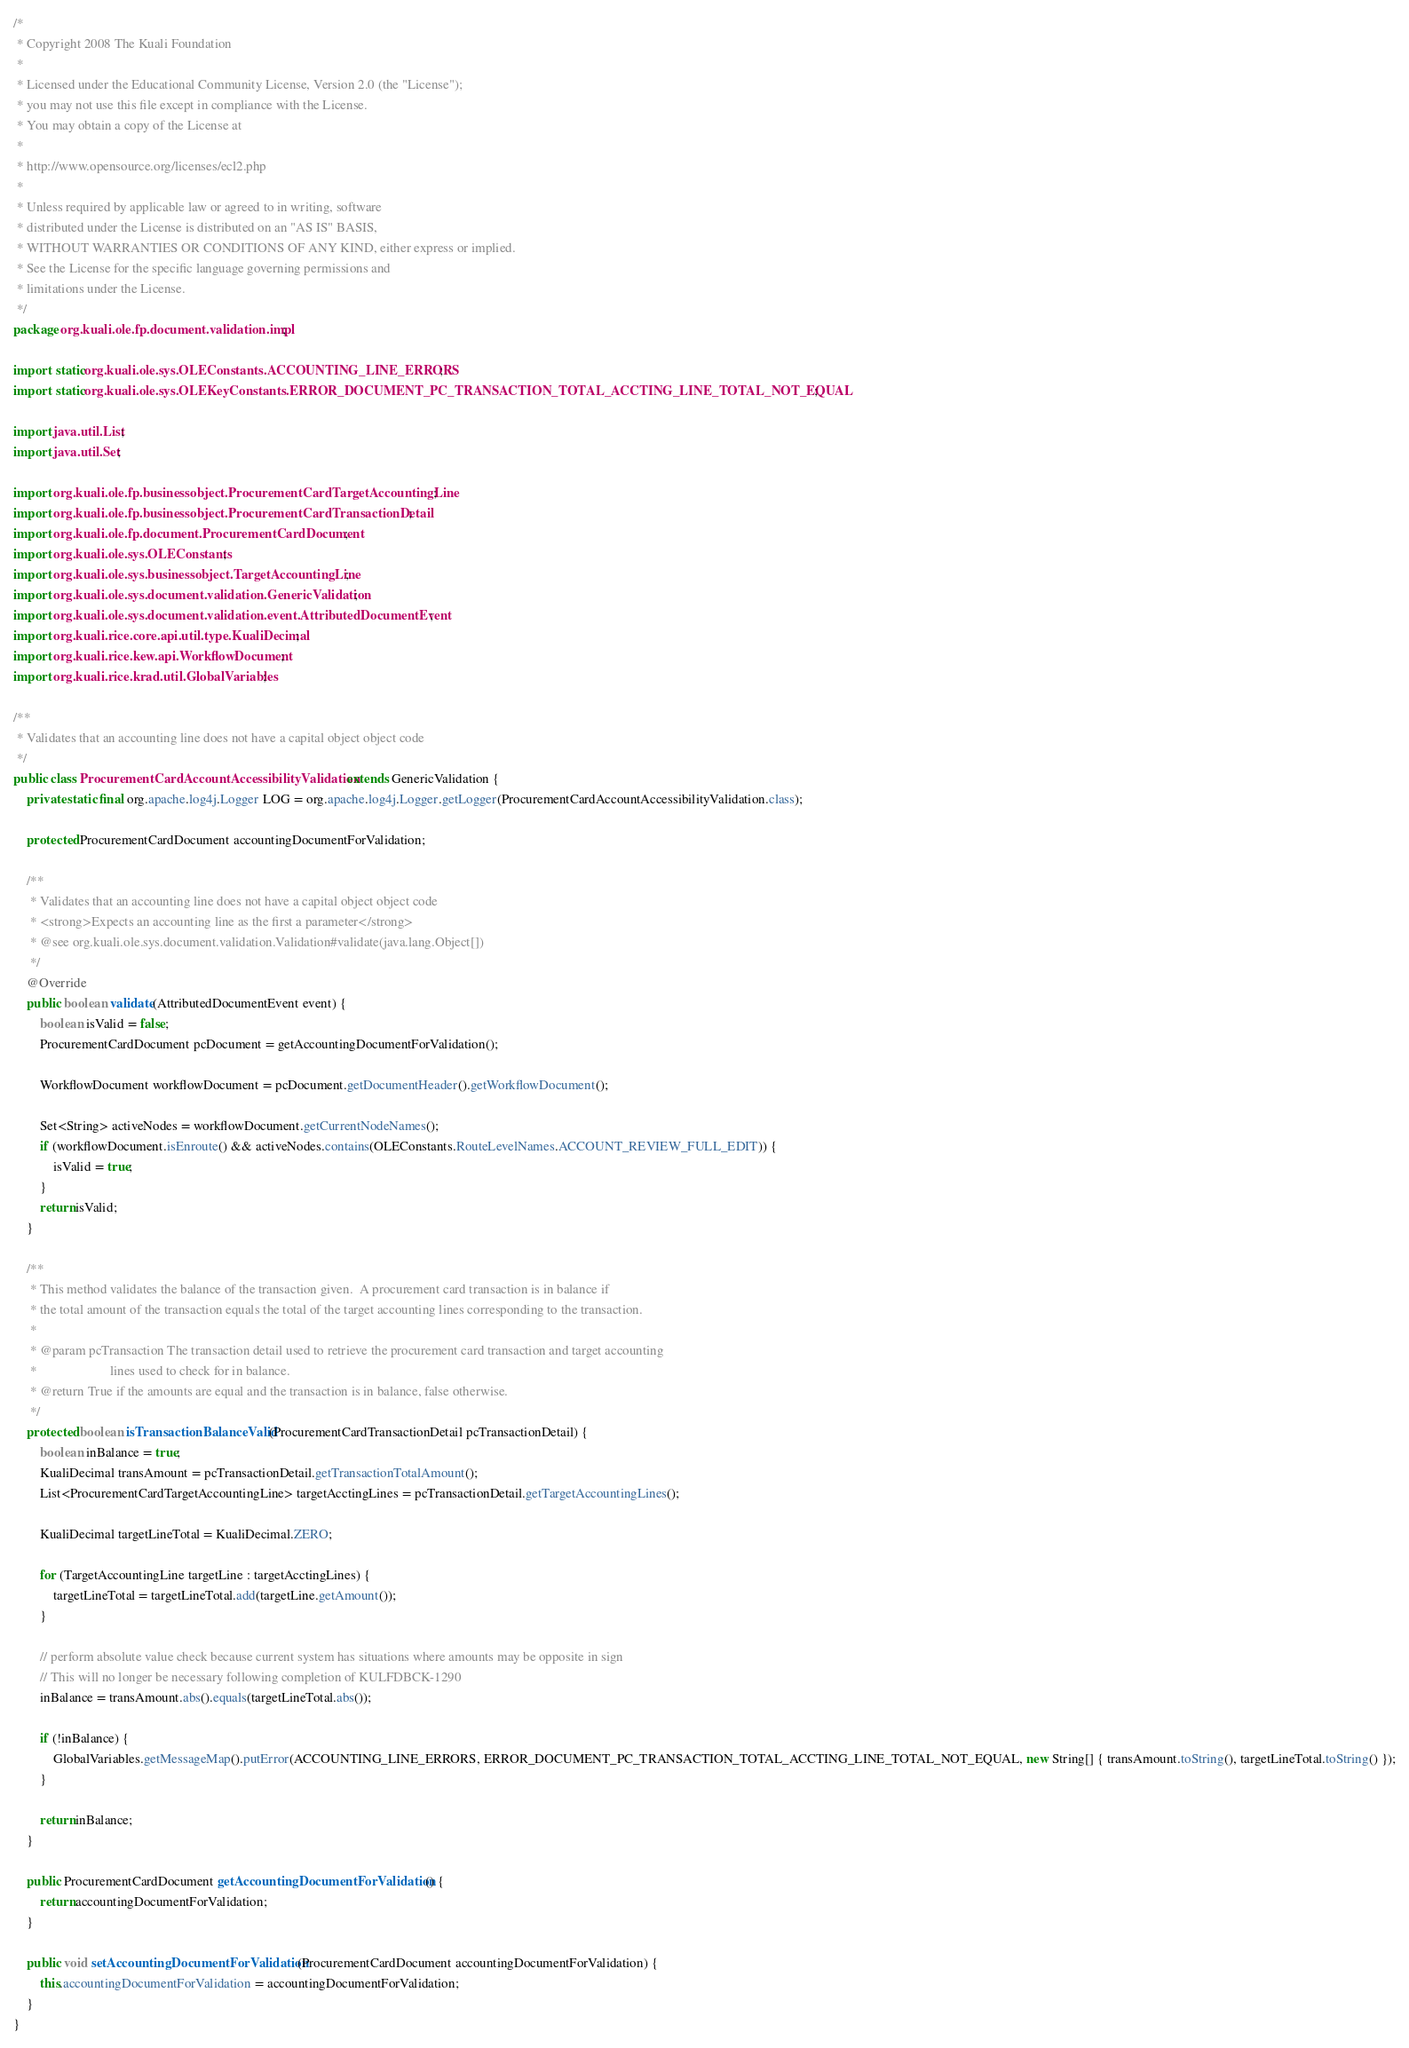Convert code to text. <code><loc_0><loc_0><loc_500><loc_500><_Java_>/*
 * Copyright 2008 The Kuali Foundation
 * 
 * Licensed under the Educational Community License, Version 2.0 (the "License");
 * you may not use this file except in compliance with the License.
 * You may obtain a copy of the License at
 * 
 * http://www.opensource.org/licenses/ecl2.php
 * 
 * Unless required by applicable law or agreed to in writing, software
 * distributed under the License is distributed on an "AS IS" BASIS,
 * WITHOUT WARRANTIES OR CONDITIONS OF ANY KIND, either express or implied.
 * See the License for the specific language governing permissions and
 * limitations under the License.
 */
package org.kuali.ole.fp.document.validation.impl;

import static org.kuali.ole.sys.OLEConstants.ACCOUNTING_LINE_ERRORS;
import static org.kuali.ole.sys.OLEKeyConstants.ERROR_DOCUMENT_PC_TRANSACTION_TOTAL_ACCTING_LINE_TOTAL_NOT_EQUAL;

import java.util.List;
import java.util.Set;

import org.kuali.ole.fp.businessobject.ProcurementCardTargetAccountingLine;
import org.kuali.ole.fp.businessobject.ProcurementCardTransactionDetail;
import org.kuali.ole.fp.document.ProcurementCardDocument;
import org.kuali.ole.sys.OLEConstants;
import org.kuali.ole.sys.businessobject.TargetAccountingLine;
import org.kuali.ole.sys.document.validation.GenericValidation;
import org.kuali.ole.sys.document.validation.event.AttributedDocumentEvent;
import org.kuali.rice.core.api.util.type.KualiDecimal;
import org.kuali.rice.kew.api.WorkflowDocument;
import org.kuali.rice.krad.util.GlobalVariables;

/**
 * Validates that an accounting line does not have a capital object object code 
 */
public class ProcurementCardAccountAccessibilityValidation extends GenericValidation {
    private static final org.apache.log4j.Logger LOG = org.apache.log4j.Logger.getLogger(ProcurementCardAccountAccessibilityValidation.class);

    protected ProcurementCardDocument accountingDocumentForValidation;

    /**
     * Validates that an accounting line does not have a capital object object code
     * <strong>Expects an accounting line as the first a parameter</strong>
     * @see org.kuali.ole.sys.document.validation.Validation#validate(java.lang.Object[])
     */
    @Override
    public boolean validate(AttributedDocumentEvent event) {
        boolean isValid = false;
        ProcurementCardDocument pcDocument = getAccountingDocumentForValidation();

        WorkflowDocument workflowDocument = pcDocument.getDocumentHeader().getWorkflowDocument();

        Set<String> activeNodes = workflowDocument.getCurrentNodeNames();
        if (workflowDocument.isEnroute() && activeNodes.contains(OLEConstants.RouteLevelNames.ACCOUNT_REVIEW_FULL_EDIT)) {
            isValid = true;
        }
        return isValid;
    }

    /**
     * This method validates the balance of the transaction given.  A procurement card transaction is in balance if 
     * the total amount of the transaction equals the total of the target accounting lines corresponding to the transaction.
     * 
     * @param pcTransaction The transaction detail used to retrieve the procurement card transaction and target accounting 
     *                      lines used to check for in balance.
     * @return True if the amounts are equal and the transaction is in balance, false otherwise.
     */
    protected boolean isTransactionBalanceValid(ProcurementCardTransactionDetail pcTransactionDetail) {
        boolean inBalance = true;
        KualiDecimal transAmount = pcTransactionDetail.getTransactionTotalAmount();
        List<ProcurementCardTargetAccountingLine> targetAcctingLines = pcTransactionDetail.getTargetAccountingLines();

        KualiDecimal targetLineTotal = KualiDecimal.ZERO;

        for (TargetAccountingLine targetLine : targetAcctingLines) {
            targetLineTotal = targetLineTotal.add(targetLine.getAmount());
        }

        // perform absolute value check because current system has situations where amounts may be opposite in sign
        // This will no longer be necessary following completion of KULFDBCK-1290
        inBalance = transAmount.abs().equals(targetLineTotal.abs());

        if (!inBalance) {
            GlobalVariables.getMessageMap().putError(ACCOUNTING_LINE_ERRORS, ERROR_DOCUMENT_PC_TRANSACTION_TOTAL_ACCTING_LINE_TOTAL_NOT_EQUAL, new String[] { transAmount.toString(), targetLineTotal.toString() });
        }

        return inBalance;
    }

    public ProcurementCardDocument getAccountingDocumentForValidation() {
        return accountingDocumentForValidation;
    }

    public void setAccountingDocumentForValidation(ProcurementCardDocument accountingDocumentForValidation) {
        this.accountingDocumentForValidation = accountingDocumentForValidation;
    }
}
</code> 